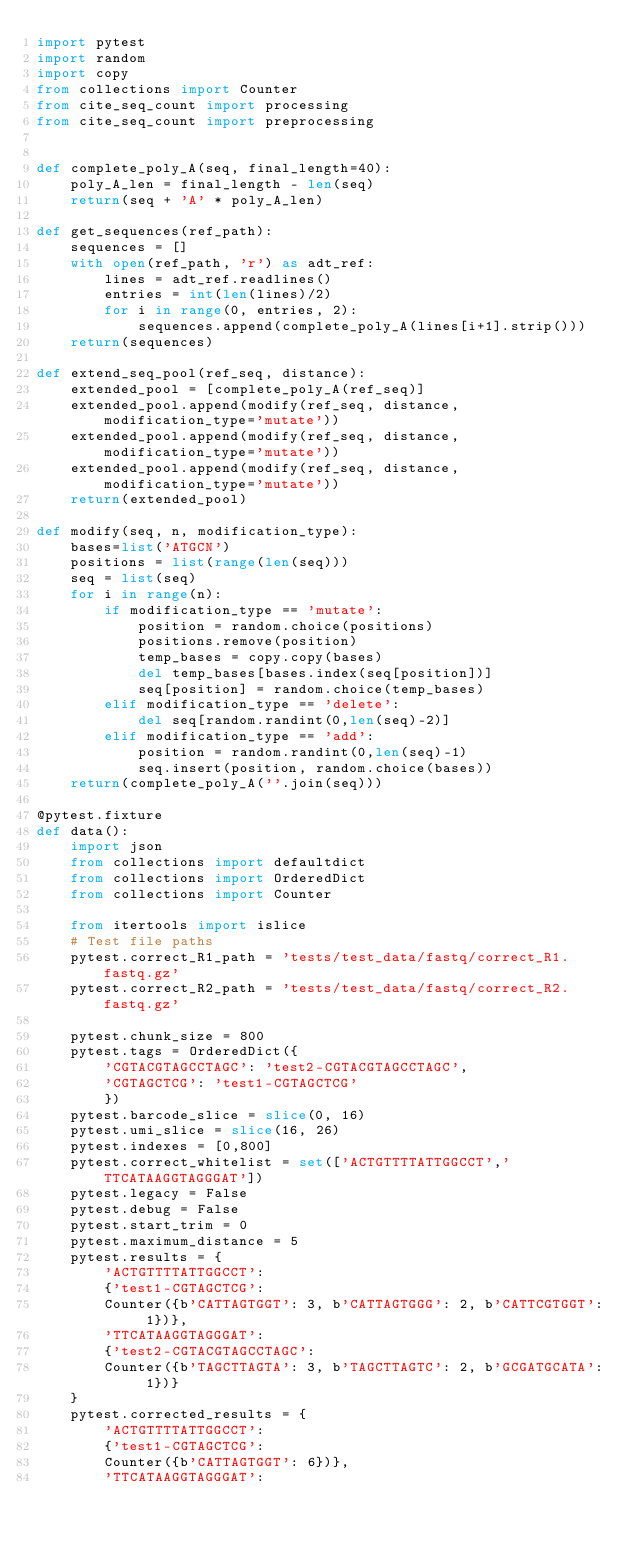<code> <loc_0><loc_0><loc_500><loc_500><_Python_>import pytest
import random
import copy
from collections import Counter
from cite_seq_count import processing
from cite_seq_count import preprocessing


def complete_poly_A(seq, final_length=40):
    poly_A_len = final_length - len(seq)
    return(seq + 'A' * poly_A_len)

def get_sequences(ref_path):
    sequences = []
    with open(ref_path, 'r') as adt_ref:
        lines = adt_ref.readlines()
        entries = int(len(lines)/2)
        for i in range(0, entries, 2):
            sequences.append(complete_poly_A(lines[i+1].strip()))
    return(sequences)
    
def extend_seq_pool(ref_seq, distance):
    extended_pool = [complete_poly_A(ref_seq)]
    extended_pool.append(modify(ref_seq, distance, modification_type='mutate'))
    extended_pool.append(modify(ref_seq, distance, modification_type='mutate'))
    extended_pool.append(modify(ref_seq, distance, modification_type='mutate'))
    return(extended_pool)

def modify(seq, n, modification_type):
    bases=list('ATGCN')
    positions = list(range(len(seq)))
    seq = list(seq)
    for i in range(n):
        if modification_type == 'mutate':
            position = random.choice(positions)
            positions.remove(position)
            temp_bases = copy.copy(bases)
            del temp_bases[bases.index(seq[position])]
            seq[position] = random.choice(temp_bases)
        elif modification_type == 'delete':
            del seq[random.randint(0,len(seq)-2)]
        elif modification_type == 'add':
            position = random.randint(0,len(seq)-1)
            seq.insert(position, random.choice(bases))
    return(complete_poly_A(''.join(seq)))

@pytest.fixture
def data():
    import json
    from collections import defaultdict
    from collections import OrderedDict
    from collections import Counter
    
    from itertools import islice
    # Test file paths
    pytest.correct_R1_path = 'tests/test_data/fastq/correct_R1.fastq.gz'
    pytest.correct_R2_path = 'tests/test_data/fastq/correct_R2.fastq.gz'
    
    pytest.chunk_size = 800
    pytest.tags = OrderedDict({
        'CGTACGTAGCCTAGC': 'test2-CGTACGTAGCCTAGC',
        'CGTAGCTCG': 'test1-CGTAGCTCG'
        })
    pytest.barcode_slice = slice(0, 16)
    pytest.umi_slice = slice(16, 26)
    pytest.indexes = [0,800]
    pytest.correct_whitelist = set(['ACTGTTTTATTGGCCT','TTCATAAGGTAGGGAT'])
    pytest.legacy = False
    pytest.debug = False
    pytest.start_trim = 0
    pytest.maximum_distance = 5
    pytest.results = {
        'ACTGTTTTATTGGCCT':
        {'test1-CGTAGCTCG':
        Counter({b'CATTAGTGGT': 3, b'CATTAGTGGG': 2, b'CATTCGTGGT': 1})},
        'TTCATAAGGTAGGGAT':
        {'test2-CGTACGTAGCCTAGC':
        Counter({b'TAGCTTAGTA': 3, b'TAGCTTAGTC': 2, b'GCGATGCATA': 1})}
    }
    pytest.corrected_results = {
        'ACTGTTTTATTGGCCT':
        {'test1-CGTAGCTCG':
        Counter({b'CATTAGTGGT': 6})},
        'TTCATAAGGTAGGGAT':</code> 